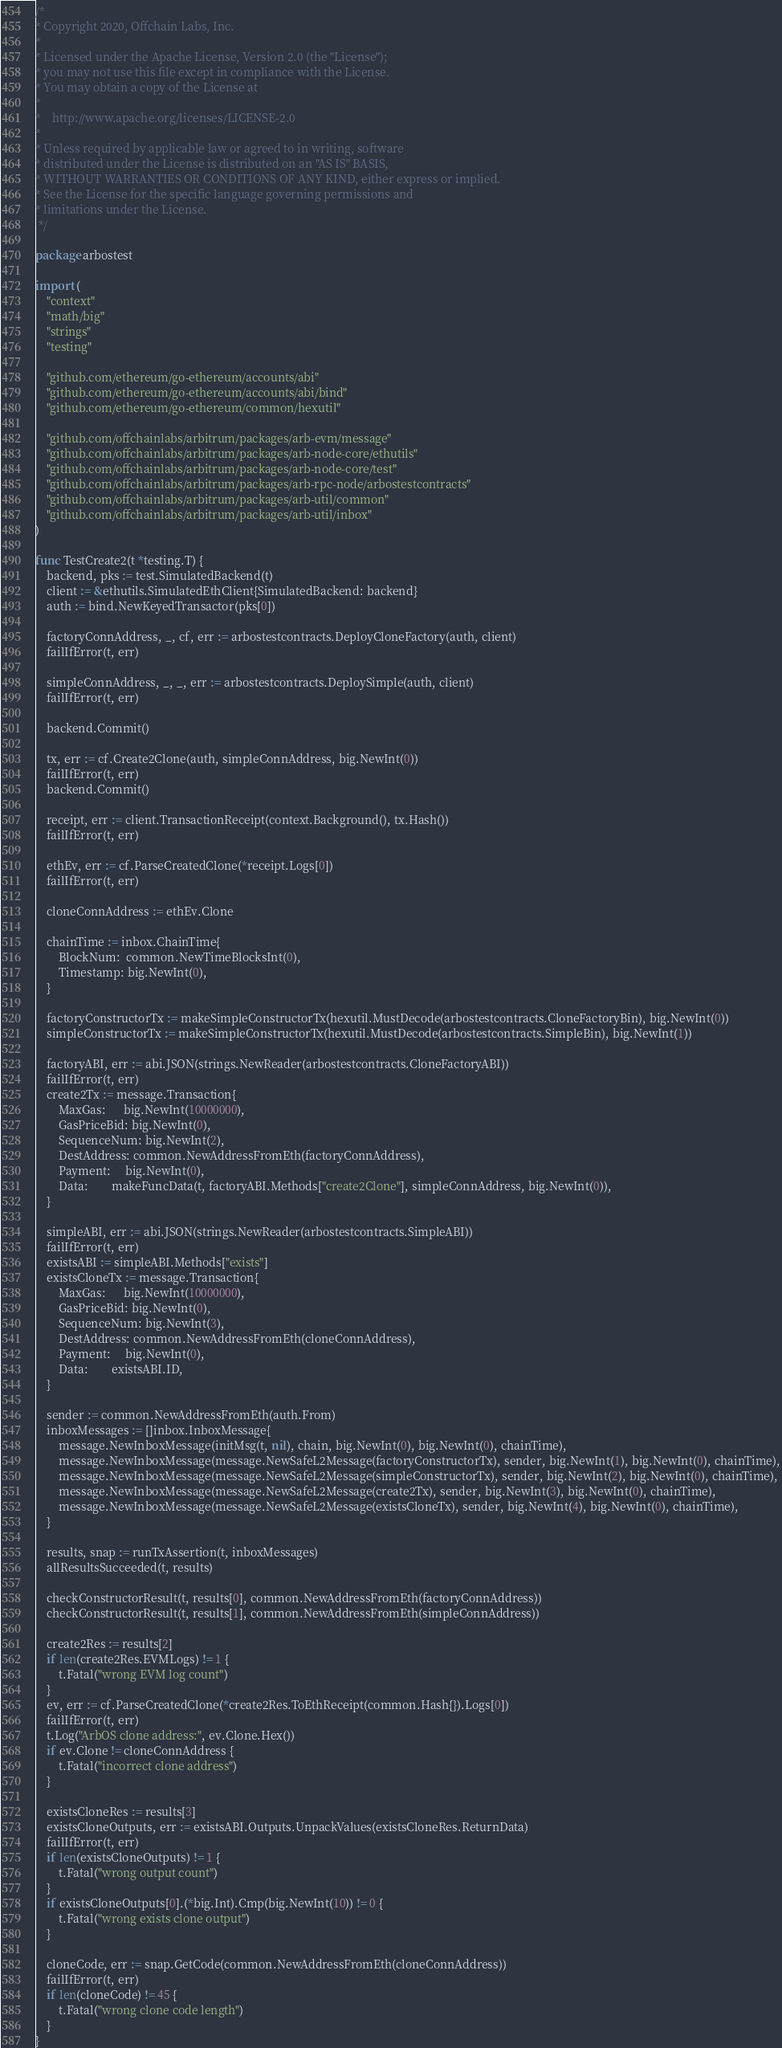<code> <loc_0><loc_0><loc_500><loc_500><_Go_>/*
* Copyright 2020, Offchain Labs, Inc.
*
* Licensed under the Apache License, Version 2.0 (the "License");
* you may not use this file except in compliance with the License.
* You may obtain a copy of the License at
*
*    http://www.apache.org/licenses/LICENSE-2.0
*
* Unless required by applicable law or agreed to in writing, software
* distributed under the License is distributed on an "AS IS" BASIS,
* WITHOUT WARRANTIES OR CONDITIONS OF ANY KIND, either express or implied.
* See the License for the specific language governing permissions and
* limitations under the License.
 */

package arbostest

import (
	"context"
	"math/big"
	"strings"
	"testing"

	"github.com/ethereum/go-ethereum/accounts/abi"
	"github.com/ethereum/go-ethereum/accounts/abi/bind"
	"github.com/ethereum/go-ethereum/common/hexutil"

	"github.com/offchainlabs/arbitrum/packages/arb-evm/message"
	"github.com/offchainlabs/arbitrum/packages/arb-node-core/ethutils"
	"github.com/offchainlabs/arbitrum/packages/arb-node-core/test"
	"github.com/offchainlabs/arbitrum/packages/arb-rpc-node/arbostestcontracts"
	"github.com/offchainlabs/arbitrum/packages/arb-util/common"
	"github.com/offchainlabs/arbitrum/packages/arb-util/inbox"
)

func TestCreate2(t *testing.T) {
	backend, pks := test.SimulatedBackend(t)
	client := &ethutils.SimulatedEthClient{SimulatedBackend: backend}
	auth := bind.NewKeyedTransactor(pks[0])

	factoryConnAddress, _, cf, err := arbostestcontracts.DeployCloneFactory(auth, client)
	failIfError(t, err)

	simpleConnAddress, _, _, err := arbostestcontracts.DeploySimple(auth, client)
	failIfError(t, err)

	backend.Commit()

	tx, err := cf.Create2Clone(auth, simpleConnAddress, big.NewInt(0))
	failIfError(t, err)
	backend.Commit()

	receipt, err := client.TransactionReceipt(context.Background(), tx.Hash())
	failIfError(t, err)

	ethEv, err := cf.ParseCreatedClone(*receipt.Logs[0])
	failIfError(t, err)

	cloneConnAddress := ethEv.Clone

	chainTime := inbox.ChainTime{
		BlockNum:  common.NewTimeBlocksInt(0),
		Timestamp: big.NewInt(0),
	}

	factoryConstructorTx := makeSimpleConstructorTx(hexutil.MustDecode(arbostestcontracts.CloneFactoryBin), big.NewInt(0))
	simpleConstructorTx := makeSimpleConstructorTx(hexutil.MustDecode(arbostestcontracts.SimpleBin), big.NewInt(1))

	factoryABI, err := abi.JSON(strings.NewReader(arbostestcontracts.CloneFactoryABI))
	failIfError(t, err)
	create2Tx := message.Transaction{
		MaxGas:      big.NewInt(10000000),
		GasPriceBid: big.NewInt(0),
		SequenceNum: big.NewInt(2),
		DestAddress: common.NewAddressFromEth(factoryConnAddress),
		Payment:     big.NewInt(0),
		Data:        makeFuncData(t, factoryABI.Methods["create2Clone"], simpleConnAddress, big.NewInt(0)),
	}

	simpleABI, err := abi.JSON(strings.NewReader(arbostestcontracts.SimpleABI))
	failIfError(t, err)
	existsABI := simpleABI.Methods["exists"]
	existsCloneTx := message.Transaction{
		MaxGas:      big.NewInt(10000000),
		GasPriceBid: big.NewInt(0),
		SequenceNum: big.NewInt(3),
		DestAddress: common.NewAddressFromEth(cloneConnAddress),
		Payment:     big.NewInt(0),
		Data:        existsABI.ID,
	}

	sender := common.NewAddressFromEth(auth.From)
	inboxMessages := []inbox.InboxMessage{
		message.NewInboxMessage(initMsg(t, nil), chain, big.NewInt(0), big.NewInt(0), chainTime),
		message.NewInboxMessage(message.NewSafeL2Message(factoryConstructorTx), sender, big.NewInt(1), big.NewInt(0), chainTime),
		message.NewInboxMessage(message.NewSafeL2Message(simpleConstructorTx), sender, big.NewInt(2), big.NewInt(0), chainTime),
		message.NewInboxMessage(message.NewSafeL2Message(create2Tx), sender, big.NewInt(3), big.NewInt(0), chainTime),
		message.NewInboxMessage(message.NewSafeL2Message(existsCloneTx), sender, big.NewInt(4), big.NewInt(0), chainTime),
	}

	results, snap := runTxAssertion(t, inboxMessages)
	allResultsSucceeded(t, results)

	checkConstructorResult(t, results[0], common.NewAddressFromEth(factoryConnAddress))
	checkConstructorResult(t, results[1], common.NewAddressFromEth(simpleConnAddress))

	create2Res := results[2]
	if len(create2Res.EVMLogs) != 1 {
		t.Fatal("wrong EVM log count")
	}
	ev, err := cf.ParseCreatedClone(*create2Res.ToEthReceipt(common.Hash{}).Logs[0])
	failIfError(t, err)
	t.Log("ArbOS clone address:", ev.Clone.Hex())
	if ev.Clone != cloneConnAddress {
		t.Fatal("incorrect clone address")
	}

	existsCloneRes := results[3]
	existsCloneOutputs, err := existsABI.Outputs.UnpackValues(existsCloneRes.ReturnData)
	failIfError(t, err)
	if len(existsCloneOutputs) != 1 {
		t.Fatal("wrong output count")
	}
	if existsCloneOutputs[0].(*big.Int).Cmp(big.NewInt(10)) != 0 {
		t.Fatal("wrong exists clone output")
	}

	cloneCode, err := snap.GetCode(common.NewAddressFromEth(cloneConnAddress))
	failIfError(t, err)
	if len(cloneCode) != 45 {
		t.Fatal("wrong clone code length")
	}
}
</code> 